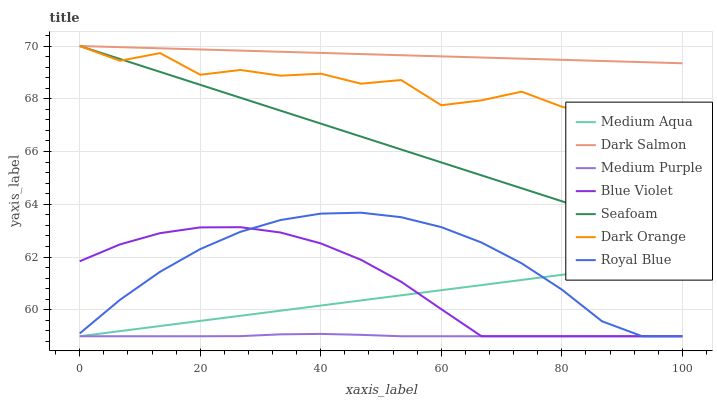Does Medium Purple have the minimum area under the curve?
Answer yes or no. Yes. Does Dark Salmon have the maximum area under the curve?
Answer yes or no. Yes. Does Seafoam have the minimum area under the curve?
Answer yes or no. No. Does Seafoam have the maximum area under the curve?
Answer yes or no. No. Is Seafoam the smoothest?
Answer yes or no. Yes. Is Dark Orange the roughest?
Answer yes or no. Yes. Is Dark Salmon the smoothest?
Answer yes or no. No. Is Dark Salmon the roughest?
Answer yes or no. No. Does Medium Purple have the lowest value?
Answer yes or no. Yes. Does Seafoam have the lowest value?
Answer yes or no. No. Does Seafoam have the highest value?
Answer yes or no. Yes. Does Medium Purple have the highest value?
Answer yes or no. No. Is Blue Violet less than Seafoam?
Answer yes or no. Yes. Is Dark Salmon greater than Royal Blue?
Answer yes or no. Yes. Does Medium Aqua intersect Royal Blue?
Answer yes or no. Yes. Is Medium Aqua less than Royal Blue?
Answer yes or no. No. Is Medium Aqua greater than Royal Blue?
Answer yes or no. No. Does Blue Violet intersect Seafoam?
Answer yes or no. No. 